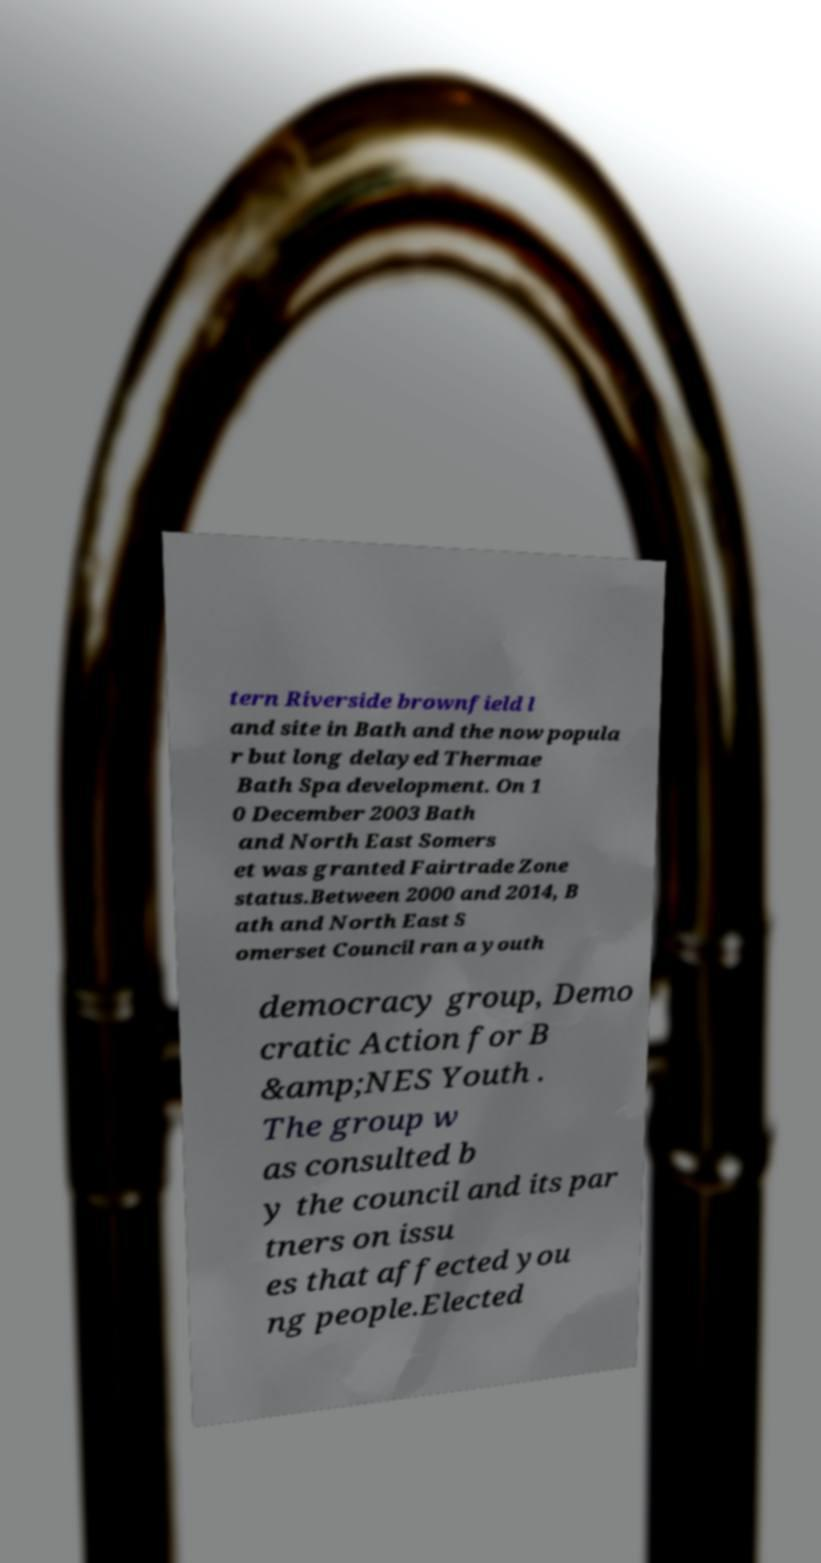Could you assist in decoding the text presented in this image and type it out clearly? tern Riverside brownfield l and site in Bath and the now popula r but long delayed Thermae Bath Spa development. On 1 0 December 2003 Bath and North East Somers et was granted Fairtrade Zone status.Between 2000 and 2014, B ath and North East S omerset Council ran a youth democracy group, Demo cratic Action for B &amp;NES Youth . The group w as consulted b y the council and its par tners on issu es that affected you ng people.Elected 